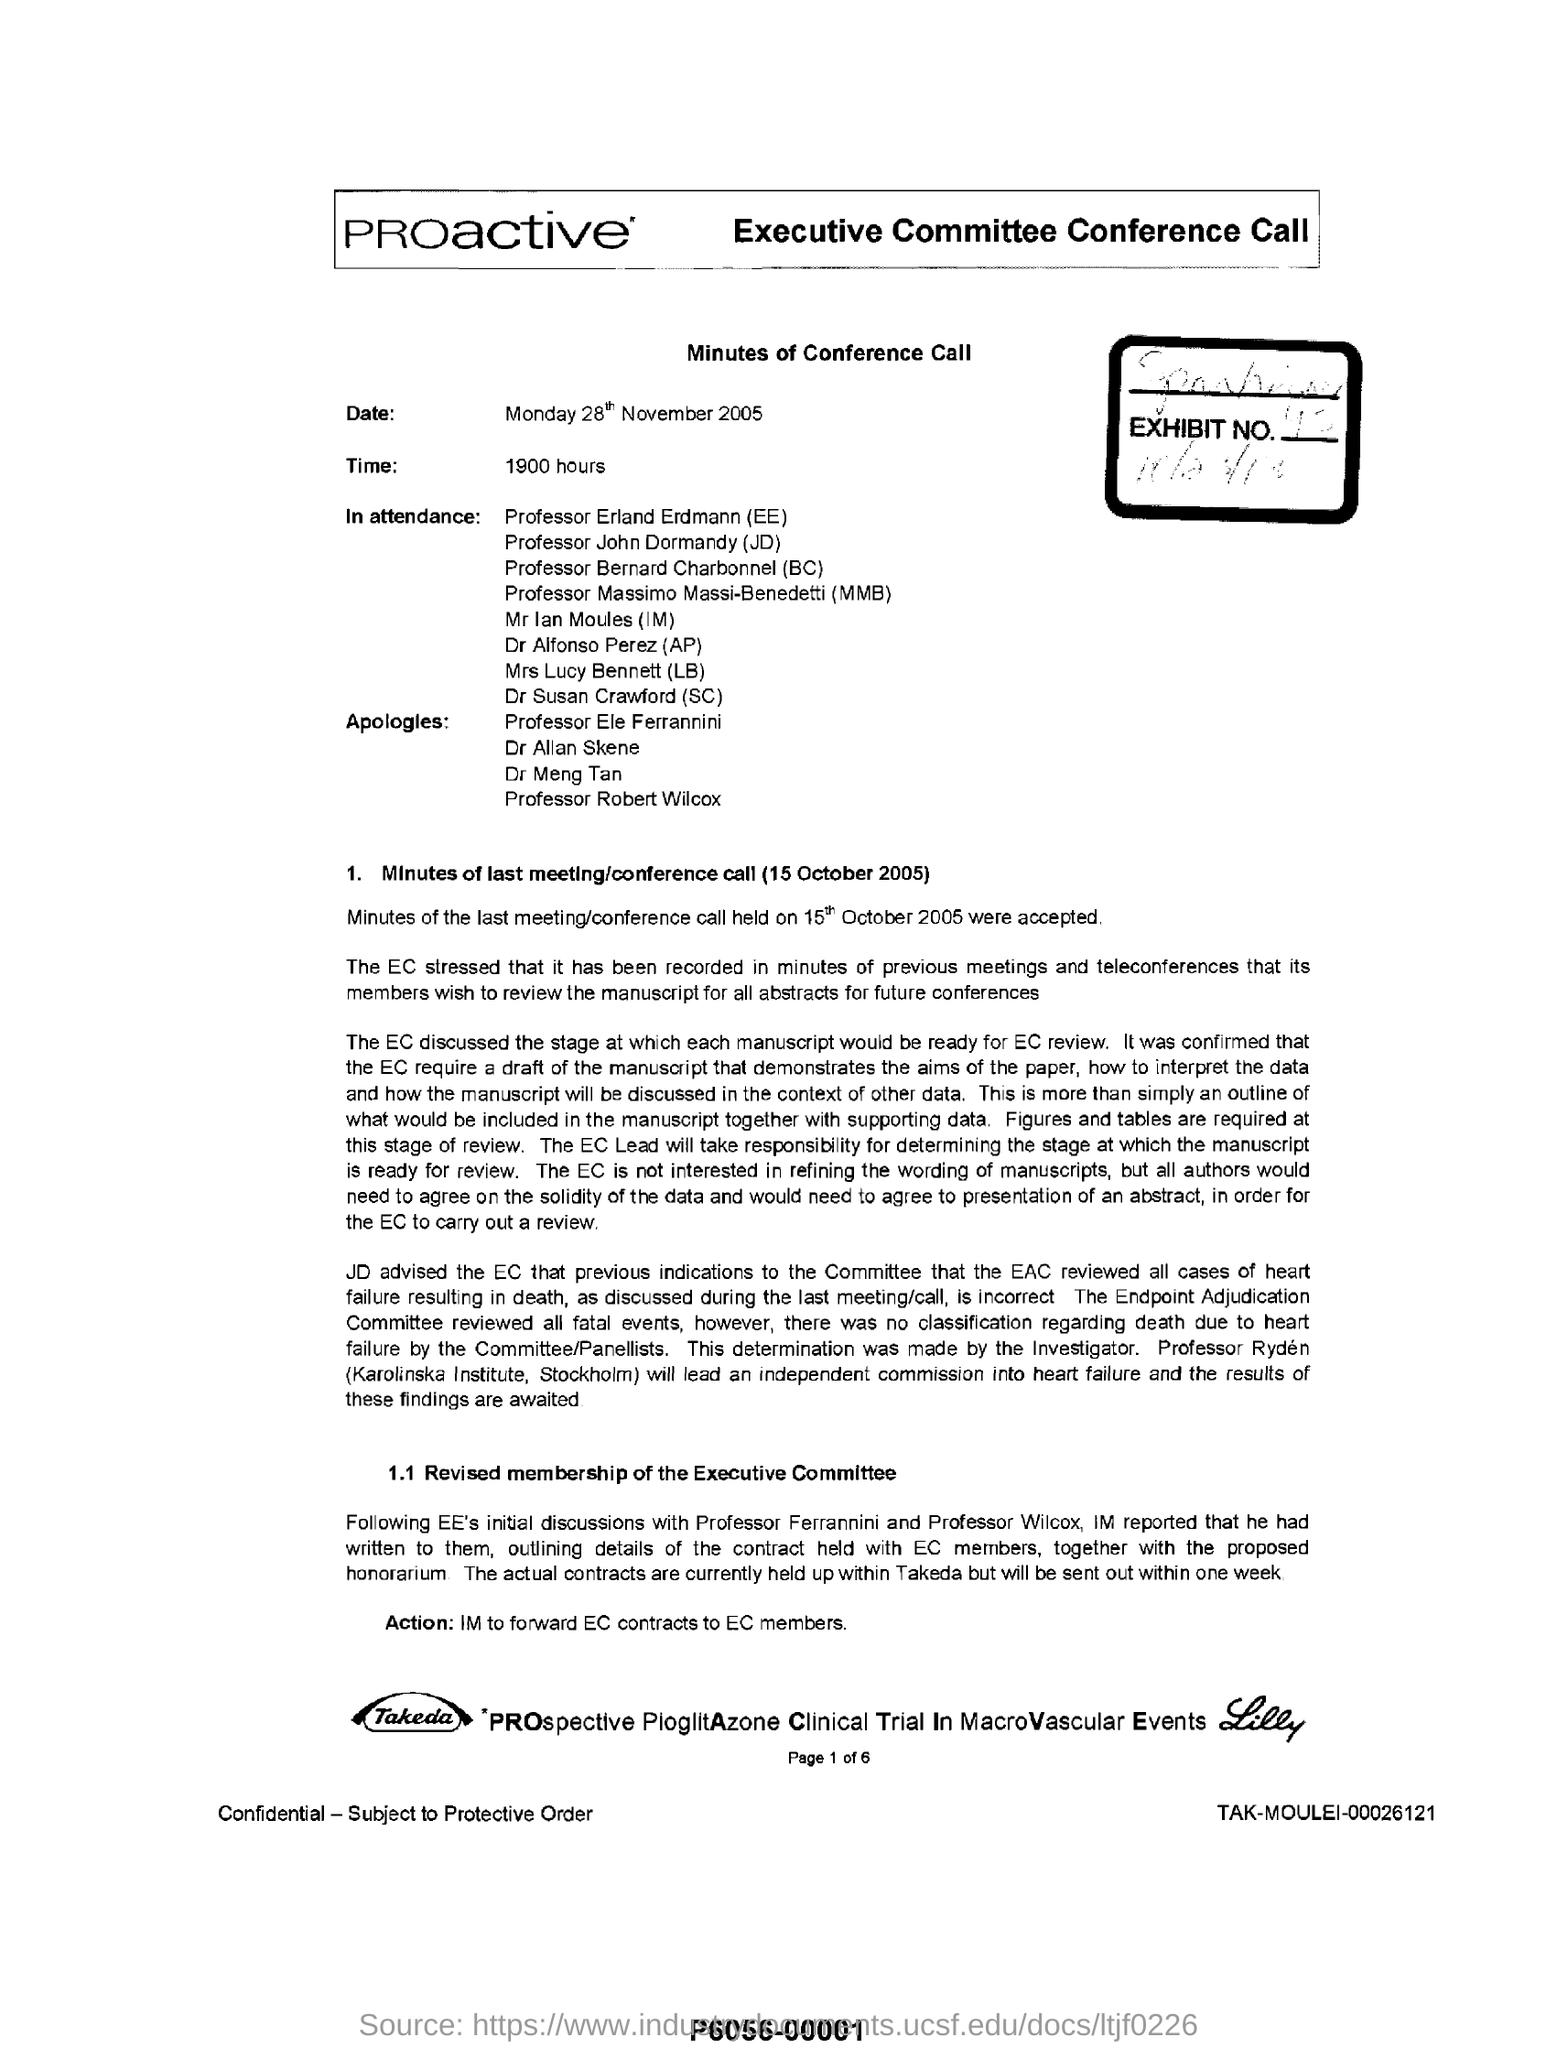List a handful of essential elements in this visual. On October 15, 2005, the last meeting/conference call was held. I apologize to Professor Ele Ferrannini, the first name listed in the apologies. The title under which the date is mentioned is "Minutes of Conference Call," and the date mentioned is Monday, 28th November 2005. 